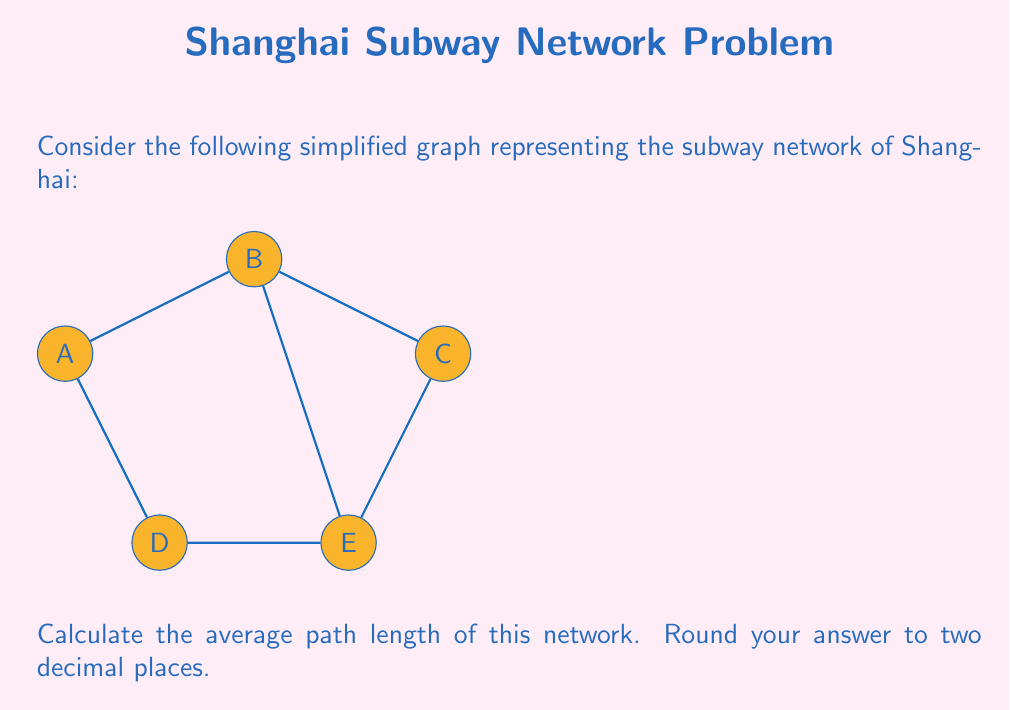Can you answer this question? To solve this problem, we'll follow these steps:

1) First, let's understand what average path length means. It's the average number of edges along the shortest paths for all possible pairs of network nodes.

2) In this graph, we have 5 nodes (A, B, C, D, E). We need to calculate the shortest path between each pair of nodes.

3) Let's list out all the shortest paths:
   A to B: 1 edge
   A to C: 2 edges
   A to D: 1 edge
   A to E: 2 edges
   B to C: 1 edge
   B to D: 2 edges
   B to E: 1 edge
   C to D: 2 edges
   C to E: 1 edge
   D to E: 1 edge

4) Now, we need to sum up all these path lengths:
   Total path length = 1 + 2 + 1 + 2 + 1 + 2 + 1 + 2 + 1 + 1 = 14

5) To get the average, we divide by the number of pairs. In a network with n nodes, the number of pairs is $\frac{n(n-1)}{2}$. Here, n = 5.

   Number of pairs = $\frac{5(5-1)}{2} = \frac{5 * 4}{2} = 10$

6) Average path length = Total path length / Number of pairs
                       = 14 / 10 = 1.4

Therefore, the average path length of this network is 1.4.
Answer: 1.40 